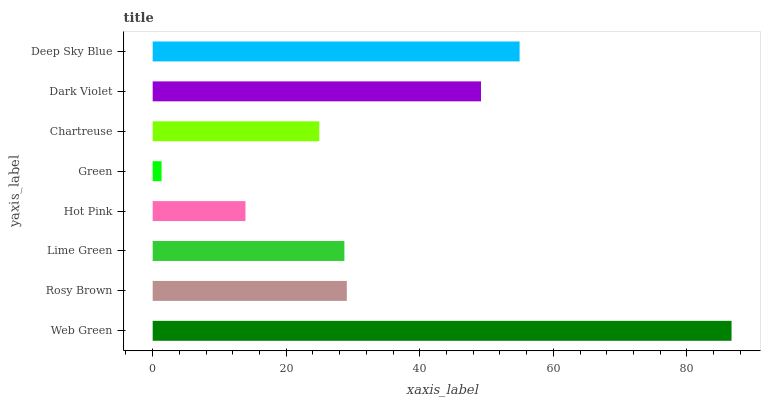Is Green the minimum?
Answer yes or no. Yes. Is Web Green the maximum?
Answer yes or no. Yes. Is Rosy Brown the minimum?
Answer yes or no. No. Is Rosy Brown the maximum?
Answer yes or no. No. Is Web Green greater than Rosy Brown?
Answer yes or no. Yes. Is Rosy Brown less than Web Green?
Answer yes or no. Yes. Is Rosy Brown greater than Web Green?
Answer yes or no. No. Is Web Green less than Rosy Brown?
Answer yes or no. No. Is Rosy Brown the high median?
Answer yes or no. Yes. Is Lime Green the low median?
Answer yes or no. Yes. Is Chartreuse the high median?
Answer yes or no. No. Is Green the low median?
Answer yes or no. No. 